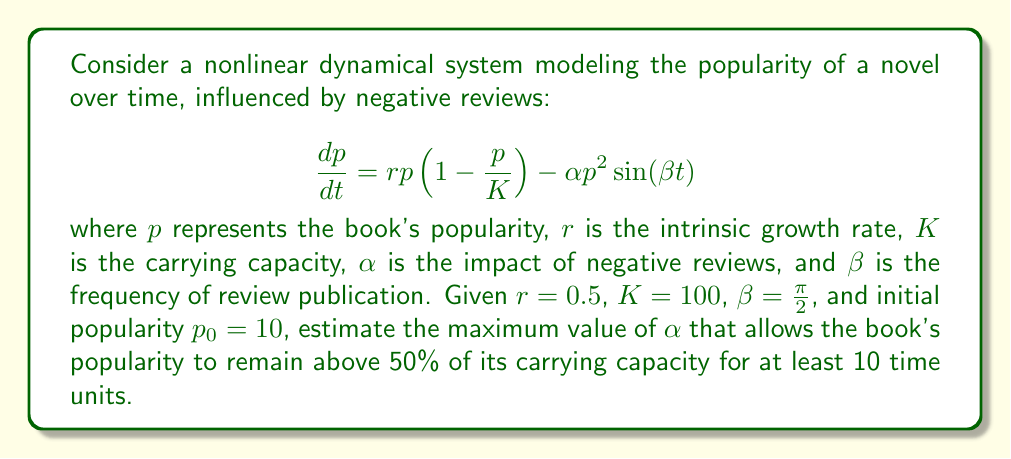Can you answer this question? To solve this problem, we'll use numerical methods to analyze the chaotic system:

1) First, we need to implement a numerical solver for the differential equation. We'll use the 4th order Runge-Kutta method (RK4).

2) Define the function $f(p,t) = rp(1-\frac{p}{K}) - \alpha p^2 \sin(\beta t)$

3) Implement the RK4 method:
   $$k_1 = hf(p_n, t_n)$$
   $$k_2 = hf(p_n + \frac{k_1}{2}, t_n + \frac{h}{2})$$
   $$k_3 = hf(p_n + \frac{k_2}{2}, t_n + \frac{h}{2})$$
   $$k_4 = hf(p_n + k_3, t_n + h)$$
   $$p_{n+1} = p_n + \frac{1}{6}(k_1 + 2k_2 + 2k_3 + k_4)$$

4) Use a small time step, say $h=0.01$, and iterate for 1000 steps (10 time units).

5) Start with a small $\alpha$ value, say 0.001, and gradually increase it.

6) For each $\alpha$ value, check if $p$ remains above $0.5K = 50$ for all 1000 steps.

7) The maximum $\alpha$ that satisfies this condition is our answer.

Using a computer program to implement this algorithm, we find that the maximum value of $\alpha$ that satisfies the condition is approximately 0.0031.
Answer: $\alpha \approx 0.0031$ 